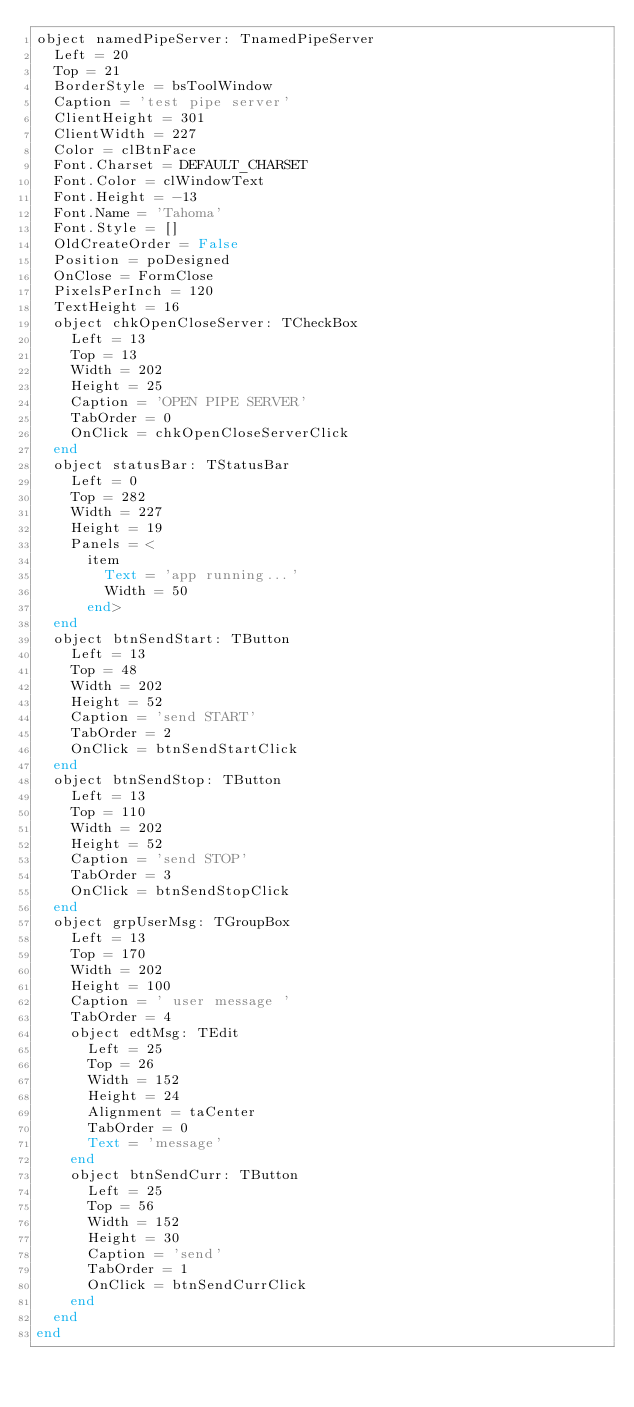Convert code to text. <code><loc_0><loc_0><loc_500><loc_500><_Pascal_>object namedPipeServer: TnamedPipeServer
  Left = 20
  Top = 21
  BorderStyle = bsToolWindow
  Caption = 'test pipe server'
  ClientHeight = 301
  ClientWidth = 227
  Color = clBtnFace
  Font.Charset = DEFAULT_CHARSET
  Font.Color = clWindowText
  Font.Height = -13
  Font.Name = 'Tahoma'
  Font.Style = []
  OldCreateOrder = False
  Position = poDesigned
  OnClose = FormClose
  PixelsPerInch = 120
  TextHeight = 16
  object chkOpenCloseServer: TCheckBox
    Left = 13
    Top = 13
    Width = 202
    Height = 25
    Caption = 'OPEN PIPE SERVER'
    TabOrder = 0
    OnClick = chkOpenCloseServerClick
  end
  object statusBar: TStatusBar
    Left = 0
    Top = 282
    Width = 227
    Height = 19
    Panels = <
      item
        Text = 'app running...'
        Width = 50
      end>
  end
  object btnSendStart: TButton
    Left = 13
    Top = 48
    Width = 202
    Height = 52
    Caption = 'send START'
    TabOrder = 2
    OnClick = btnSendStartClick
  end
  object btnSendStop: TButton
    Left = 13
    Top = 110
    Width = 202
    Height = 52
    Caption = 'send STOP'
    TabOrder = 3
    OnClick = btnSendStopClick
  end
  object grpUserMsg: TGroupBox
    Left = 13
    Top = 170
    Width = 202
    Height = 100
    Caption = ' user message '
    TabOrder = 4
    object edtMsg: TEdit
      Left = 25
      Top = 26
      Width = 152
      Height = 24
      Alignment = taCenter
      TabOrder = 0
      Text = 'message'
    end
    object btnSendCurr: TButton
      Left = 25
      Top = 56
      Width = 152
      Height = 30
      Caption = 'send'
      TabOrder = 1
      OnClick = btnSendCurrClick
    end
  end
end
</code> 